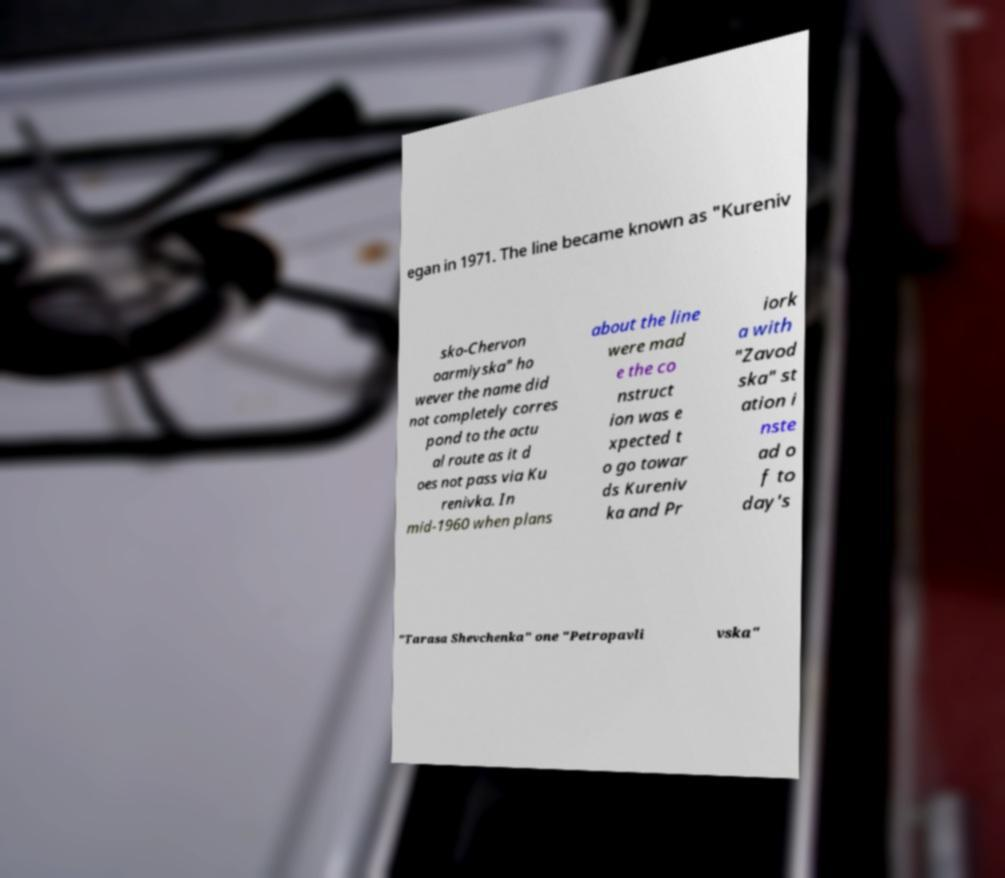What messages or text are displayed in this image? I need them in a readable, typed format. egan in 1971. The line became known as "Kureniv sko-Chervon oarmiyska" ho wever the name did not completely corres pond to the actu al route as it d oes not pass via Ku renivka. In mid-1960 when plans about the line were mad e the co nstruct ion was e xpected t o go towar ds Kureniv ka and Pr iork a with "Zavod ska" st ation i nste ad o f to day's "Tarasa Shevchenka" one "Petropavli vska" 